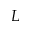<formula> <loc_0><loc_0><loc_500><loc_500>L</formula> 